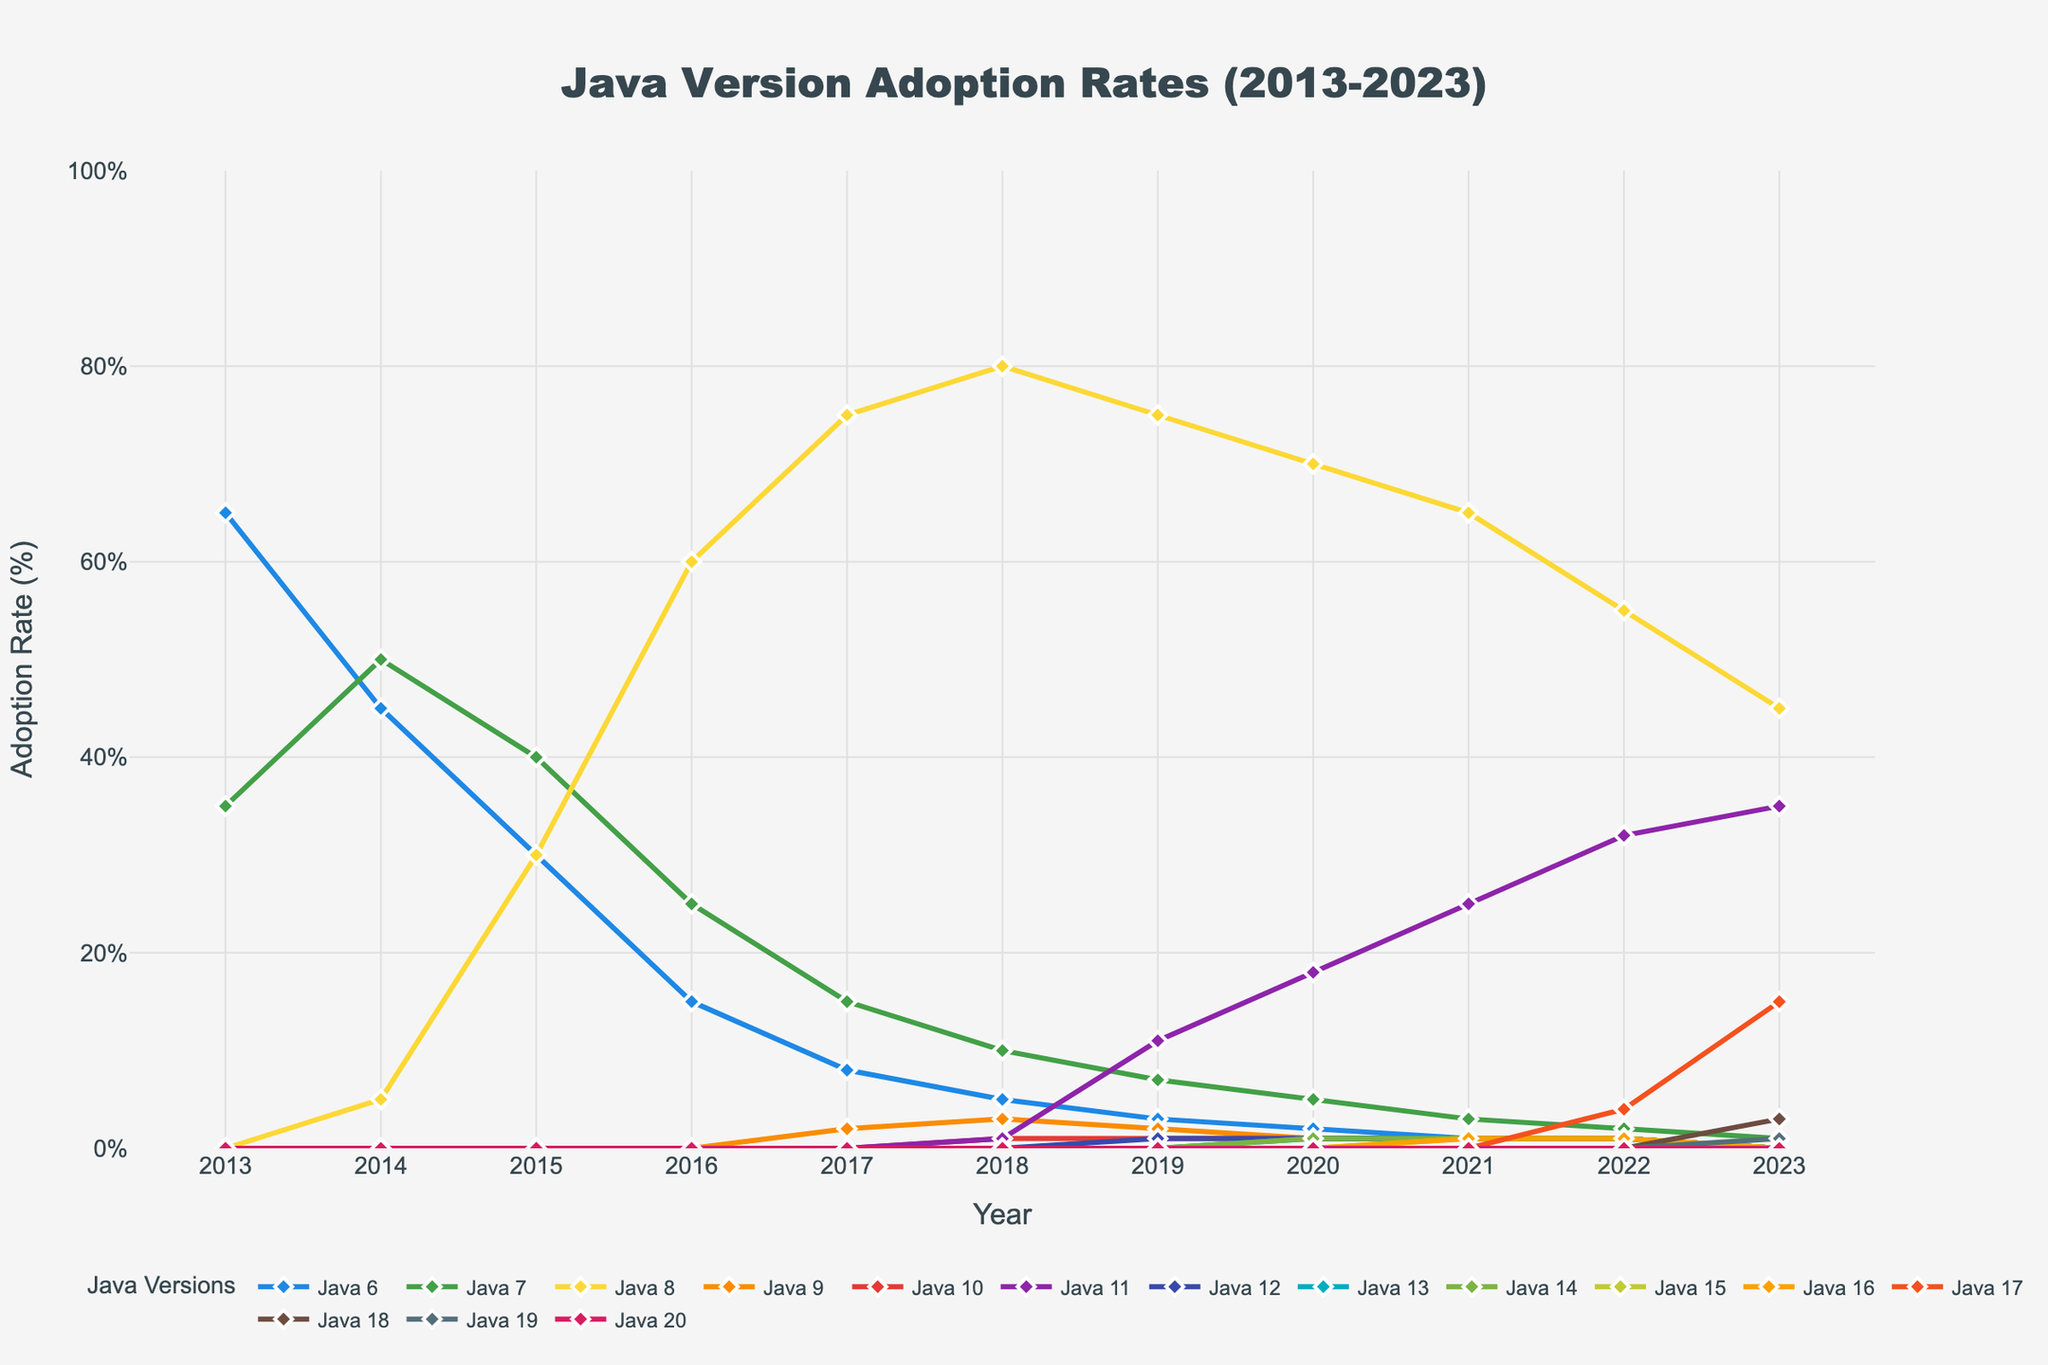Which Java version had the highest adoption rate in 2013? To find the answer, look at the highest point on the line chart for the year 2013. The Java version with the highest adoption rate is Java 6 at 65%.
Answer: Java 6 Between 2016 and 2017, which Java version showed substantial growth in adoption rate? Between 2016 and 2017, the adoption rate line for Java 8 shows a significant increase from 60% to 75%. Other versions do not show such noticeable growth during this period.
Answer: Java 8 What is the trend of Java 7's adoption rate from 2013 to 2023? Java 7 started with an adoption rate of 35% in 2013 and gradually declined each year to finally reach 1% in 2023. This indicates a consistent downward trend over the decade.
Answer: Declining In which year did Java 11 first surpass Java 7 in adoption rate? By comparing the lines for Java 11 and Java 7, it is seen that Java 11 surpassed Java 7 in 2019 with 11% for Java 11 and 7% for Java 7.
Answer: 2019 Identify the year when Java 8 had its peak adoption rate and state the percentage. Java 8 reached its peak adoption rate in 2018 with a rate of 80%, the highest value on its line graph.
Answer: 2018 and 80% How does the adoption rate of Java 17 in 2023 compare to Java 8 in the same year? In 2023, Java 17 has an adoption rate of 15% while Java 8 is at 45%. This demonstrates Java 8 has a higher adoption rate than Java 17 in 2023.
Answer: Java 8 is higher What was the combined adoption rate of Java 6 and Java 8 in 2014? In 2014, Java 6 had an adoption rate of 45% and Java 8 had 5%. Adding them together yields a combined adoption rate of 50%.
Answer: 50% Which Java version shows the most steady increase in adoption rate after its introduction? Java 11 shows a steady and consistent increase from 2018 to 2023, starting from 1% in 2018 and reaching 35% in 2023 without any drops.
Answer: Java 11 How does the adoption rate for Java 9 in 2019 compare to its rate in 2018? In 2018, the adoption rate for Java 9 was 3%, and it slightly declined to 2% in 2019, indicating a small decrease.
Answer: Decreased What was the difference in the adoption rate of Java 8 and Java 10 in 2020? In 2020, Java 8 had an adoption rate of 70% and Java 10 had 1%. The difference is 70% - 1% = 69%.
Answer: 69% 